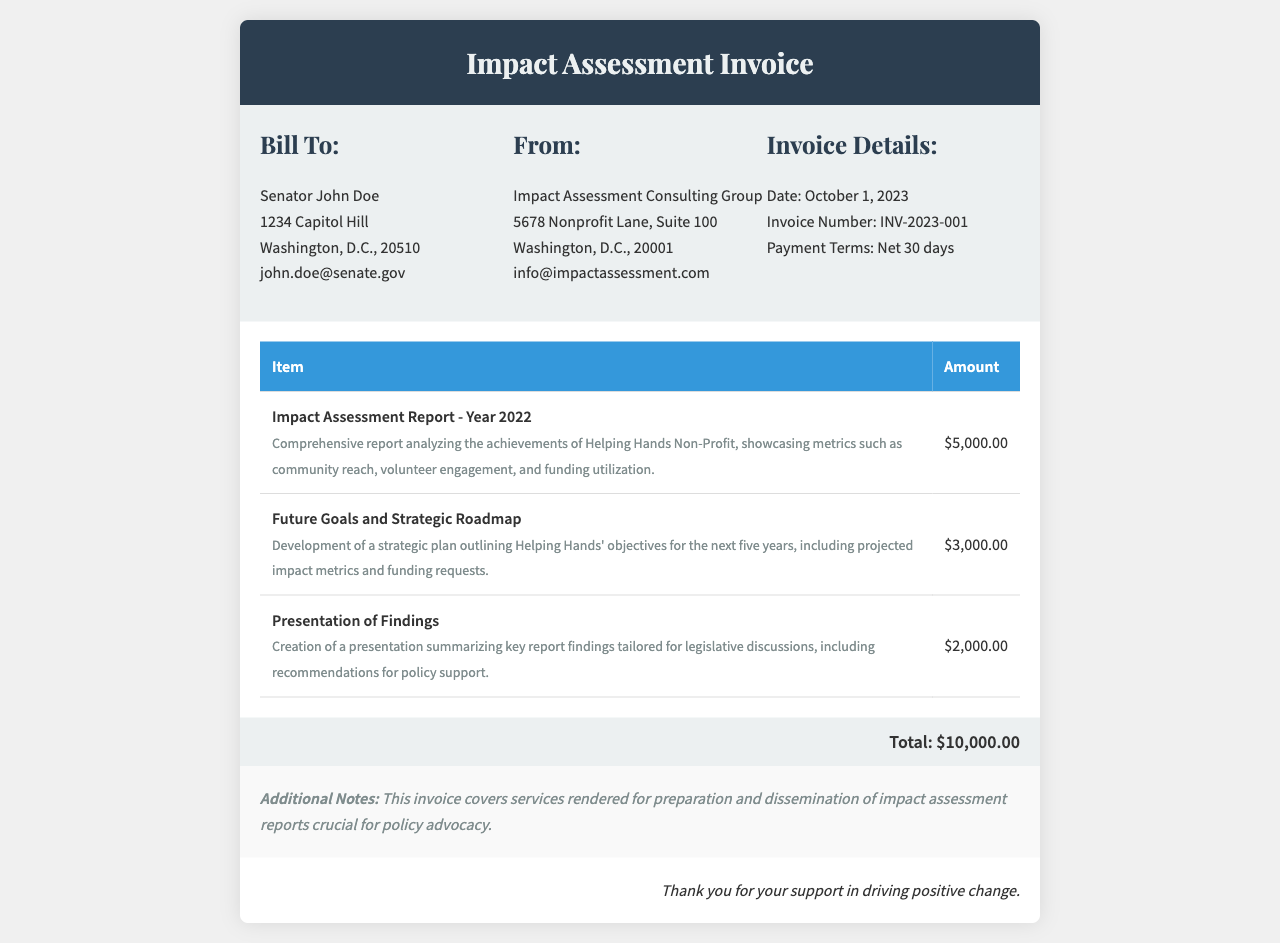what is the invoice number? The invoice number is listed in the invoice details section, which is INV-2023-001.
Answer: INV-2023-001 who is the bill to? The "Bill To" section contains the name of the senator receiving the invoice, which is Senator John Doe.
Answer: Senator John Doe what is the total amount due? The total amount is shown at the bottom of the invoice after all items listed, which totals $10,000.00.
Answer: $10,000.00 what service relates to the amount of $3,000.00? This amount corresponds to the development of a strategic plan for the organization's future goals and objectives.
Answer: Future Goals and Strategic Roadmap when is the payment due? The payment terms specify that payment is due within 30 days of the invoice date, which is stated as Net 30 days.
Answer: Net 30 days what is the main focus of the impact assessment report? The report focuses on analyzing the achievements of the Helping Hands Non-Profit, covering various metrics.
Answer: Comprehensive report analyzing the achievements what additional notes are provided in the invoice? The additional notes section mentions that the invoice covers services for impact assessment crucial for policy advocacy.
Answer: This invoice covers services rendered for preparation and dissemination of impact assessment reports crucial for policy advocacy who issued the invoice? The "From" section contains the name of the consulting group that issued the invoice, which is Impact Assessment Consulting Group.
Answer: Impact Assessment Consulting Group 